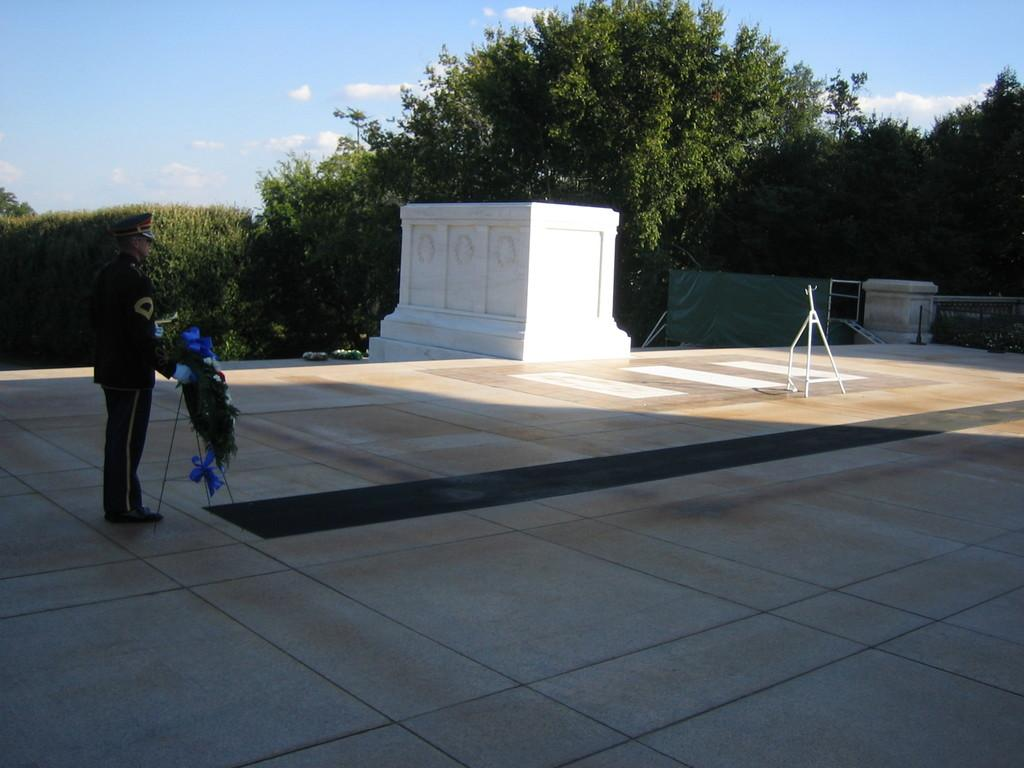What is the main subject of the image? There is a man in the image. What is the man doing in the image? The man is standing and holding a stand with flowers. What is the man wearing on his head? The man is wearing a cap. What can be seen in the background of the image? There are trees visible in the image. How would you describe the sky in the image? The sky is blue and cloudy. What type of potato is the man planting in the image? There is no potato present in the image; the man is holding a stand with flowers. How many seeds can be seen in the man's hand in the image? There are no seeds visible in the image; the man is holding a stand with flowers. 